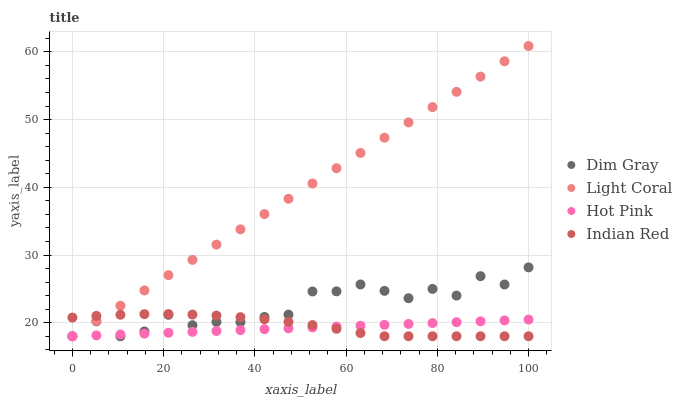Does Hot Pink have the minimum area under the curve?
Answer yes or no. Yes. Does Light Coral have the maximum area under the curve?
Answer yes or no. Yes. Does Dim Gray have the minimum area under the curve?
Answer yes or no. No. Does Dim Gray have the maximum area under the curve?
Answer yes or no. No. Is Hot Pink the smoothest?
Answer yes or no. Yes. Is Dim Gray the roughest?
Answer yes or no. Yes. Is Indian Red the smoothest?
Answer yes or no. No. Is Indian Red the roughest?
Answer yes or no. No. Does Light Coral have the lowest value?
Answer yes or no. Yes. Does Light Coral have the highest value?
Answer yes or no. Yes. Does Dim Gray have the highest value?
Answer yes or no. No. Does Dim Gray intersect Indian Red?
Answer yes or no. Yes. Is Dim Gray less than Indian Red?
Answer yes or no. No. Is Dim Gray greater than Indian Red?
Answer yes or no. No. 